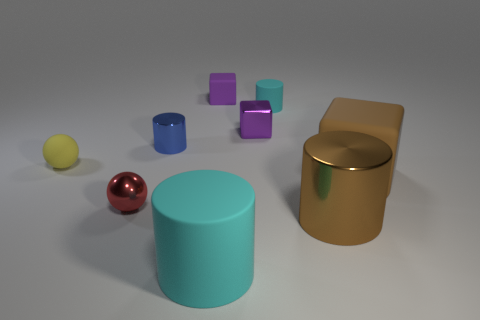There is a tiny thing that is the same color as the metal block; what material is it?
Keep it short and to the point. Rubber. What is the big brown block made of?
Ensure brevity in your answer.  Rubber. Are there any brown cubes?
Your answer should be very brief. Yes. What color is the thing that is in front of the big metal cylinder?
Offer a very short reply. Cyan. There is a shiny cylinder that is right of the cyan thing in front of the big brown block; how many small purple metal things are left of it?
Provide a short and direct response. 1. There is a tiny thing that is in front of the purple metal cube and to the right of the metal ball; what is its material?
Provide a succinct answer. Metal. Are the tiny cyan object and the cyan cylinder that is left of the purple matte block made of the same material?
Your answer should be very brief. Yes. Are there more big brown shiny cylinders that are to the right of the blue metal object than yellow spheres to the right of the brown rubber block?
Keep it short and to the point. Yes. The big brown metal object is what shape?
Your answer should be compact. Cylinder. Do the tiny purple cube behind the purple metal block and the tiny ball that is in front of the tiny yellow thing have the same material?
Your answer should be compact. No. 